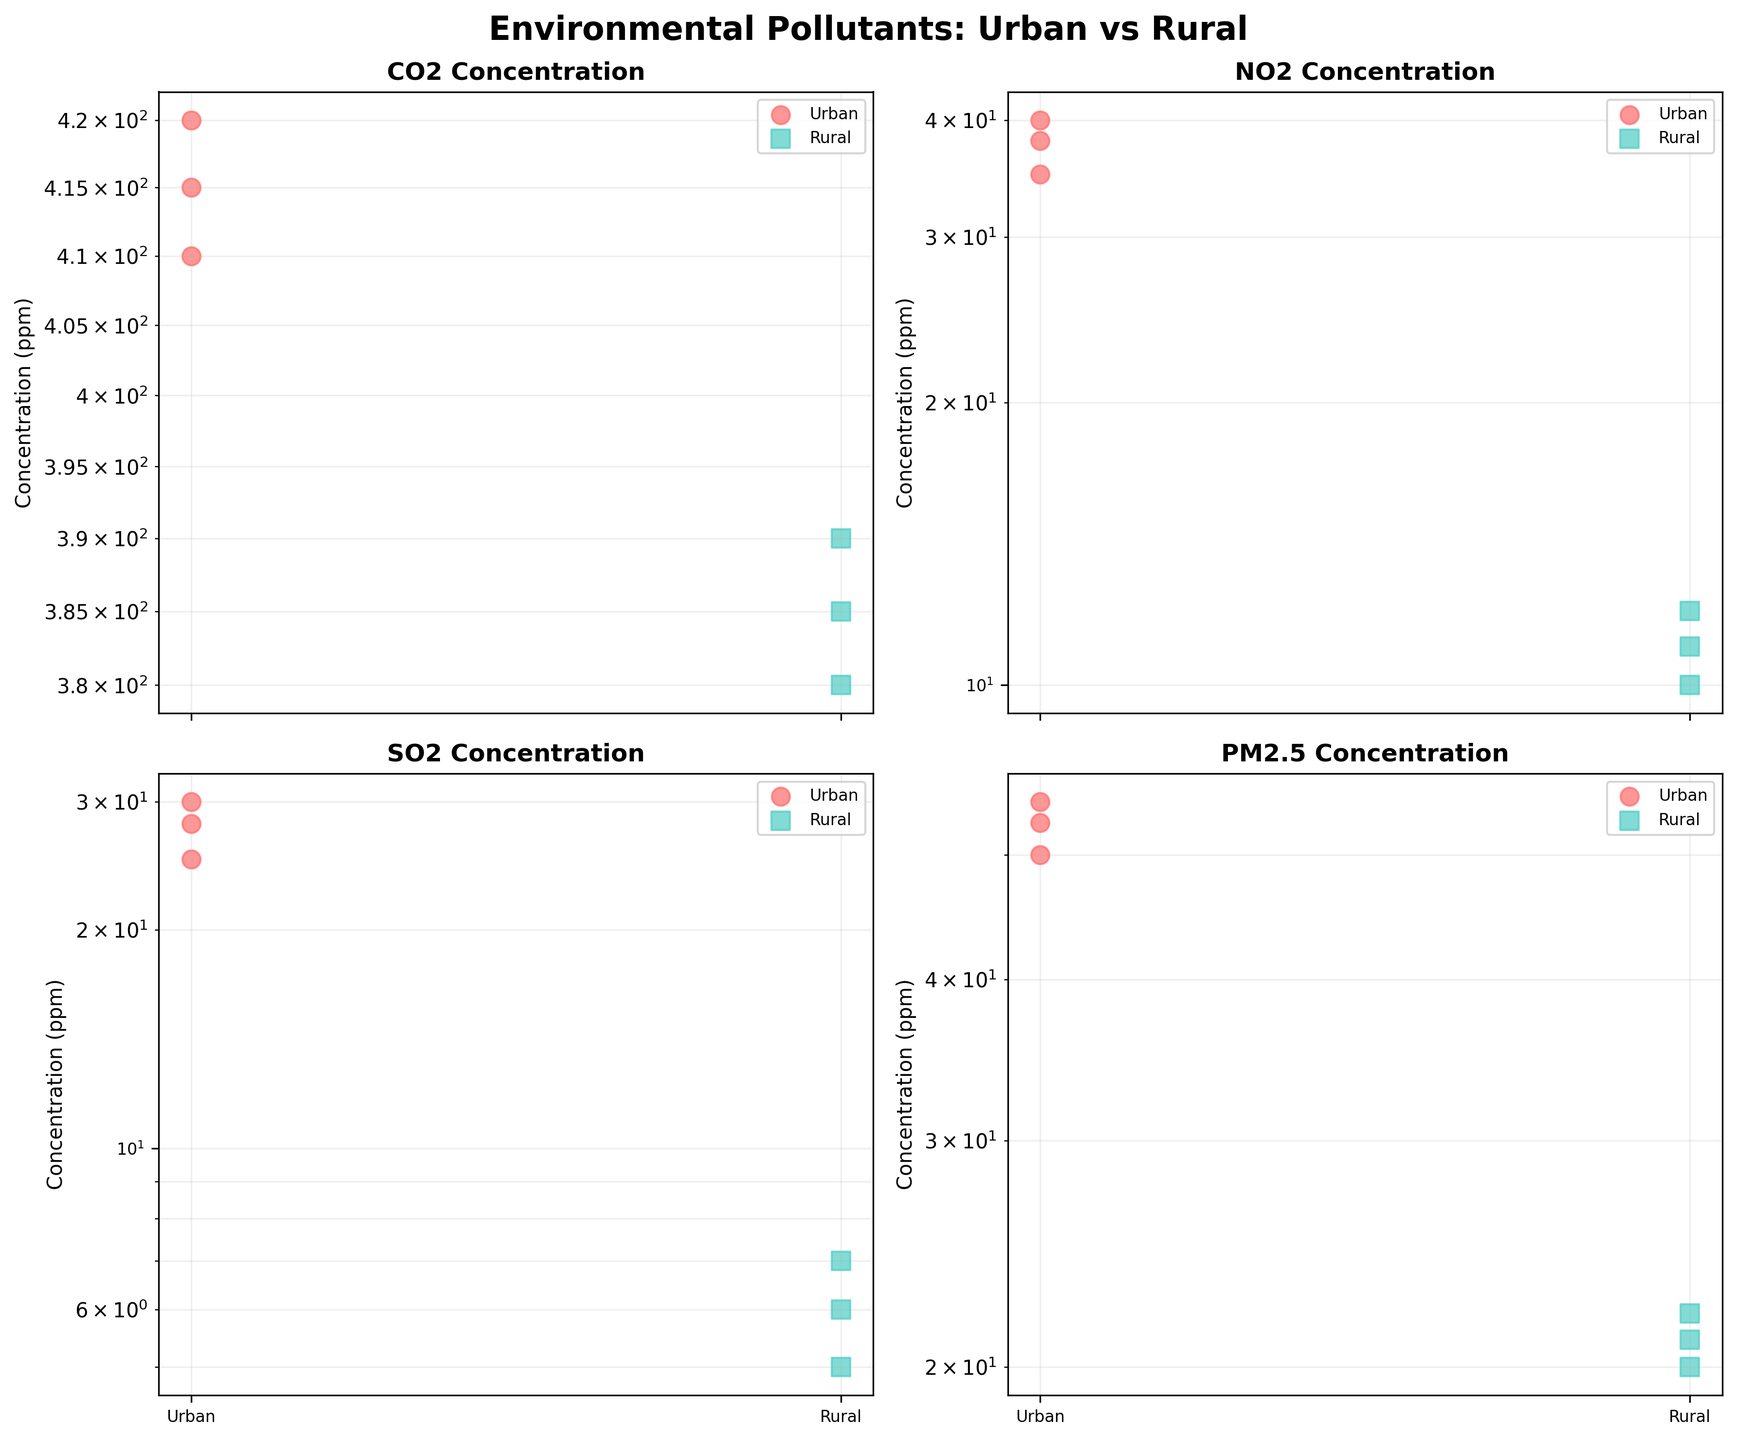What pollutants are being compared in the figure? The figure's subplots are titled and each subplot shows a specific pollutant. The pollutants are CO2, NO2, SO2, and PM2.5.
Answer: CO2, NO2, SO2, PM2.5 Which area has a higher concentration of NO2, Urban or Rural? In the NO2 subplot, the concentrations for the urban area (35, 40, 38 ppm) are all higher compared to the rural area (10, 12, 11 ppm).
Answer: Urban What's the average concentration of CO2 in rural areas? The CO2 concentrations in rural areas are 380, 385, and 390 ppm. The average is calculated as (380 + 385 + 390) / 3 = 385 ppm.
Answer: 385 ppm How does the concentration of SO2 in urban areas compare to rural areas? In the SO2 subplot, the urban concentrations (25, 30, 28 ppm) are significantly higher than the rural concentrations (5, 7, 6 ppm).
Answer: Urban concentrations are higher Which pollutant shows the greatest difference in concentration between Urban and Rural areas? By comparing the concentration ranges in each subplot, NO2 shows the most significant difference, with urban levels (35-40 ppm) far exceeding rural levels (10-12 ppm).
Answer: NO2 Is the figure using a linear or a log scale for the y-axis? The y-axis of each subplot is labeled 'Concentration (ppm)' and uses a log scale, which is necessary considering the wide range of pollutant concentrations.
Answer: Log scale What is the purpose of using different colors and markers in the figure? The color and marker shape differentiates between Urban (red circles) and Rural (green squares) areas, making it clear to distinguish the concentration data for each location visually.
Answer: To differentiate between Urban and Rural areas Which pollutant has the smallest concentration values in rural areas? The subplot for SO2, representing rural concentrations of 5, 7, and 6 ppm, shows the smallest values compared to other pollutants.
Answer: SO2 For PM2.5, what is the ratio of the highest concentration in urban areas to the highest in rural areas? The highest PM2.5 concentration in urban areas is 55 ppm, while in rural areas it is 22 ppm. The ratio is 55 / 22 = 2.5.
Answer: 2.5 